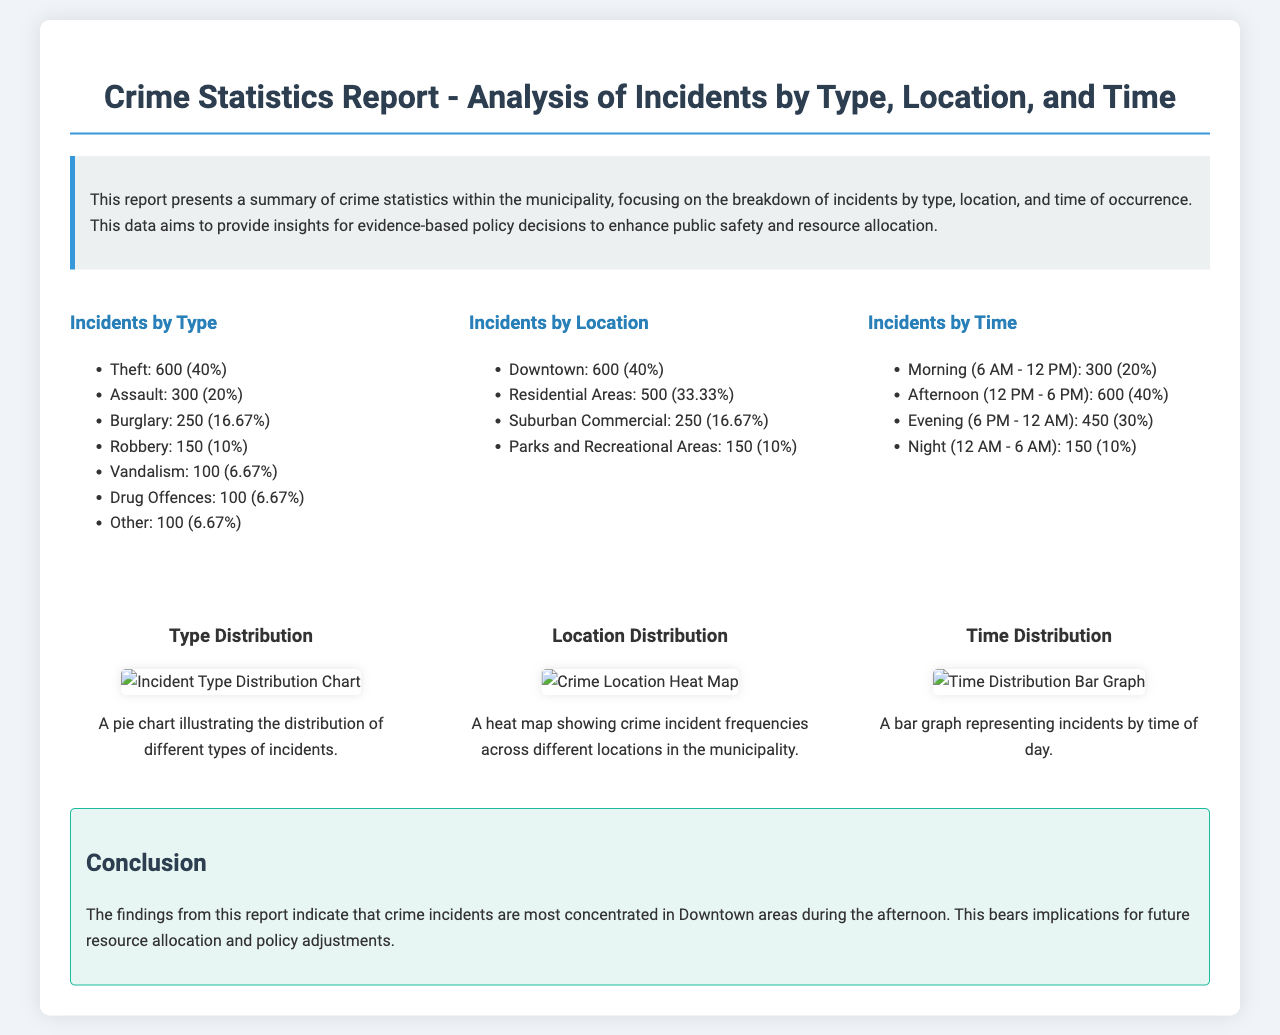What percentage of incidents are attributed to Theft? The document states that Theft accounts for 600 incidents, which is 40% of the total reported crimes.
Answer: 40% Which area has the highest number of incidents? According to the document, the area with the highest number of incidents is Downtown, with 600 occurrences.
Answer: Downtown What is the total number of incidents recorded in the evening? The document lists 450 incidents occurring during the evening time (6 PM - 12 AM).
Answer: 450 What type of crime constitutes 10% of the total incidents? The document indicates that Robbery represents 150 incidents, amounting to 10% of total crimes.
Answer: Robbery During which time period are there the most incidents reported? The highest number of reported incidents occurs during the Afternoon (12 PM - 6 PM), with 600 incidents.
Answer: Afternoon Which type of crime has the same percentage as Drug Offences? The document states that Drug Offences and Other both account for 100 incidents each, which is 6.67% of total crimes.
Answer: Other What conclusion is drawn regarding resource allocation? The report concludes that crime incidents are concentrated in Downtown areas during the afternoon, suggesting the need for policy adjustments.
Answer: Policy adjustments How many incidents are reported in Parks and Recreational Areas? The document reports a total of 150 incidents occurring in Parks and Recreational Areas.
Answer: 150 What visual representation is given for the type distribution of incidents? The document includes a pie chart that illustrates the distribution of different types of incidents.
Answer: Pie chart 